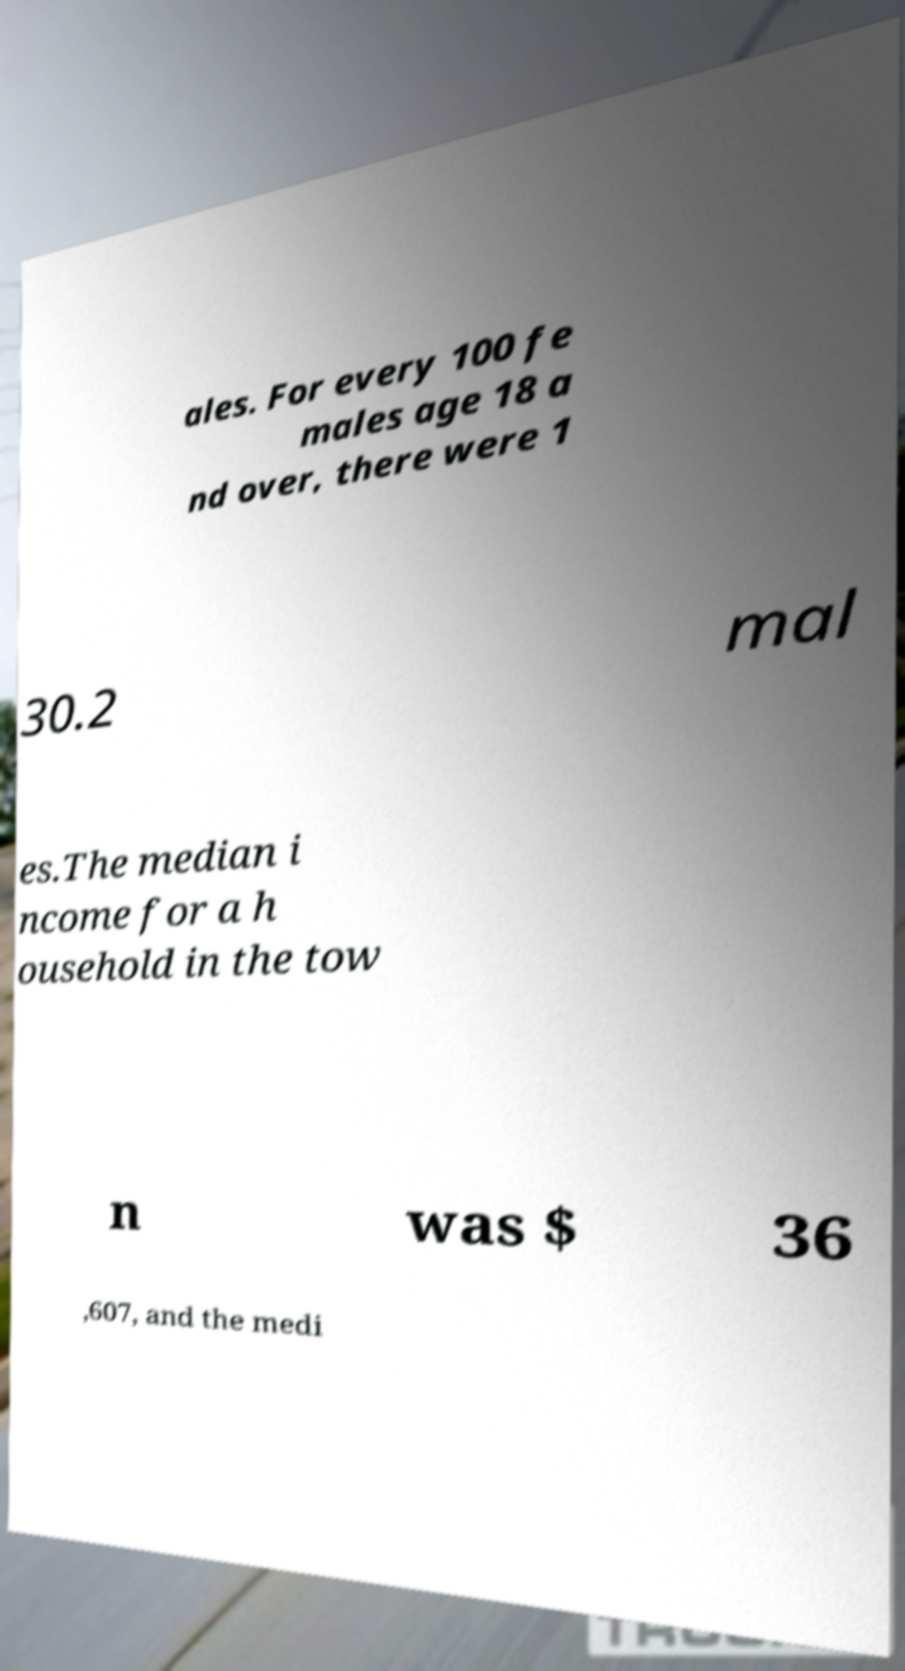Can you read and provide the text displayed in the image?This photo seems to have some interesting text. Can you extract and type it out for me? ales. For every 100 fe males age 18 a nd over, there were 1 30.2 mal es.The median i ncome for a h ousehold in the tow n was $ 36 ,607, and the medi 